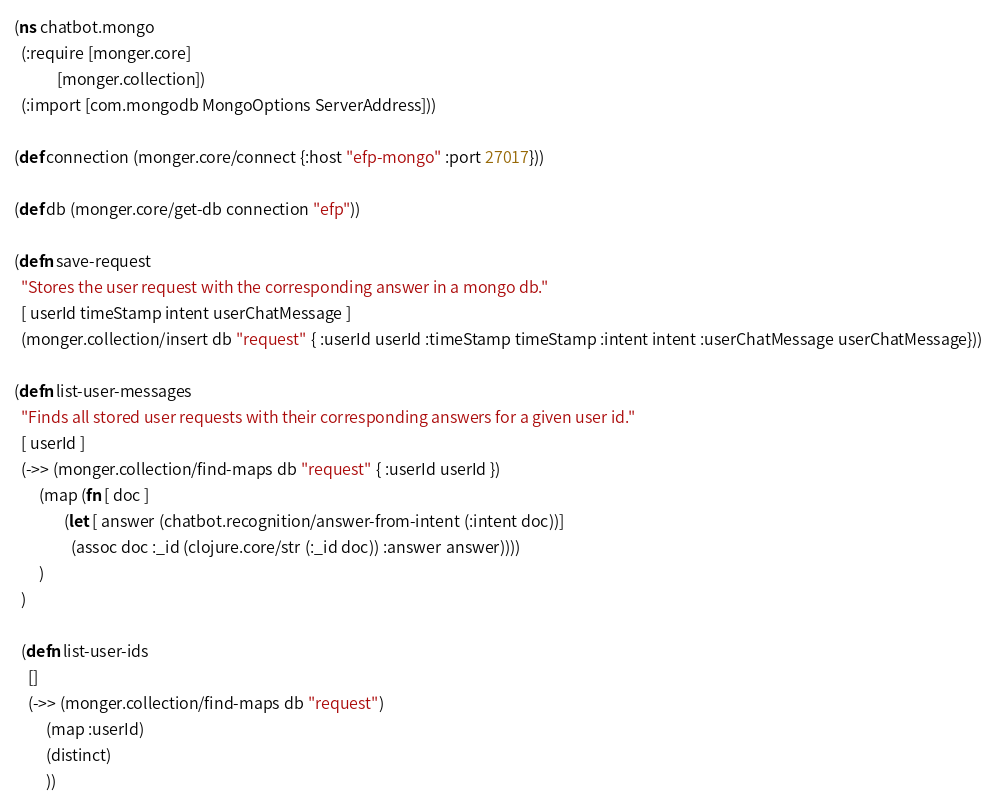<code> <loc_0><loc_0><loc_500><loc_500><_Clojure_>(ns chatbot.mongo
  (:require [monger.core]
            [monger.collection])
  (:import [com.mongodb MongoOptions ServerAddress]))

(def connection (monger.core/connect {:host "efp-mongo" :port 27017}))

(def db (monger.core/get-db connection "efp"))

(defn save-request
  "Stores the user request with the corresponding answer in a mongo db."
  [ userId timeStamp intent userChatMessage ]
  (monger.collection/insert db "request" { :userId userId :timeStamp timeStamp :intent intent :userChatMessage userChatMessage}))

(defn list-user-messages
  "Finds all stored user requests with their corresponding answers for a given user id."
  [ userId ]
  (->> (monger.collection/find-maps db "request" { :userId userId })
       (map (fn [ doc ]
              (let [ answer (chatbot.recognition/answer-from-intent (:intent doc))]
                (assoc doc :_id (clojure.core/str (:_id doc)) :answer answer))))
       )
  )

  (defn list-user-ids
    []
    (->> (monger.collection/find-maps db "request")
         (map :userId)
         (distinct)
         ))
</code> 